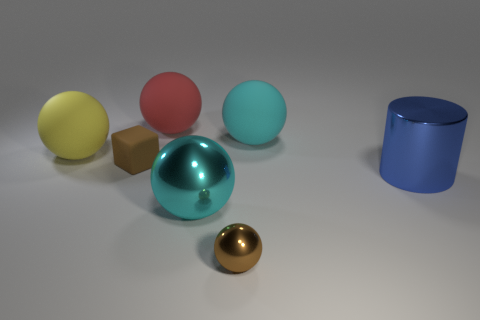Is there any other thing that is the same color as the metal cylinder?
Make the answer very short. No. Are the cyan ball in front of the large metal cylinder and the red object behind the small brown rubber cube made of the same material?
Offer a very short reply. No. What material is the big ball that is both in front of the cyan matte object and to the right of the big yellow thing?
Provide a short and direct response. Metal. Do the big blue metal thing and the matte thing that is right of the tiny brown sphere have the same shape?
Provide a short and direct response. No. What is the big cyan sphere that is in front of the blue thing that is in front of the small thing left of the red matte object made of?
Offer a very short reply. Metal. How many other objects are the same size as the brown matte cube?
Provide a short and direct response. 1. Do the rubber cube and the big metal sphere have the same color?
Ensure brevity in your answer.  No. There is a large cyan object that is in front of the shiny object that is right of the big cyan rubber ball; how many large cyan objects are behind it?
Keep it short and to the point. 1. There is a cyan object that is right of the cyan object that is in front of the brown rubber thing; what is its material?
Your response must be concise. Rubber. Is there another small rubber thing that has the same shape as the cyan rubber object?
Make the answer very short. No. 